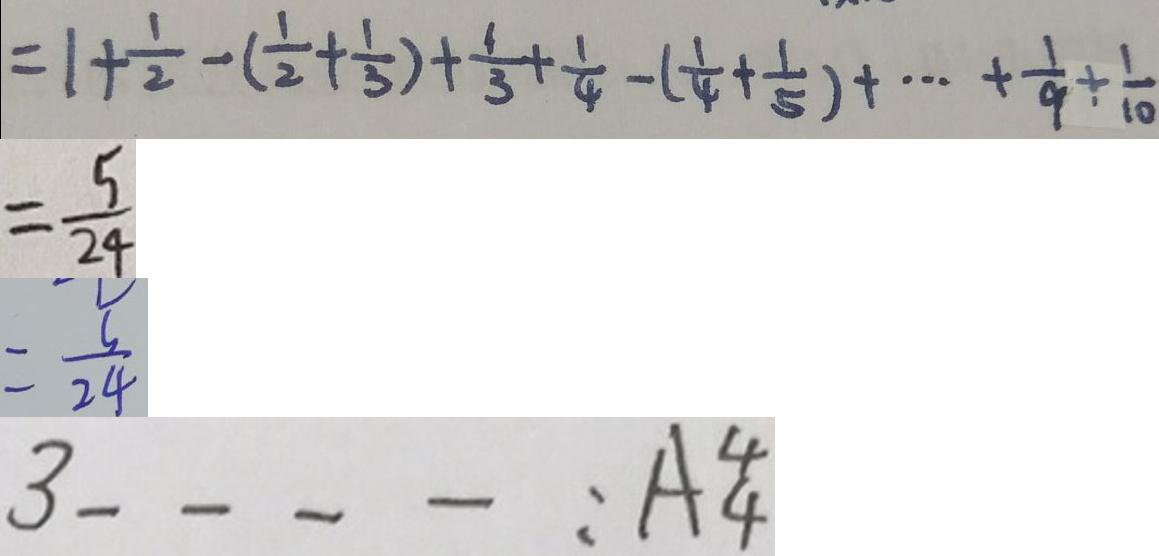Convert formula to latex. <formula><loc_0><loc_0><loc_500><loc_500>= 1 + \frac { 1 } { 2 } - ( \frac { 1 } { 2 } + \frac { 1 } { 3 } ) + \frac { 1 } { 3 } + \frac { 1 } { 4 } - ( \frac { 1 } { 4 } + \frac { 1 } { 5 } ) + \cdots + \frac { 1 } { 9 } + \frac { 1 } { 1 0 } 
 = \frac { 5 } { 2 4 } 
 = \frac { 5 } { 2 4 } 
 3 \_ \_ \_ \_ : A _ { 4 } ^ { 4 }</formula> 